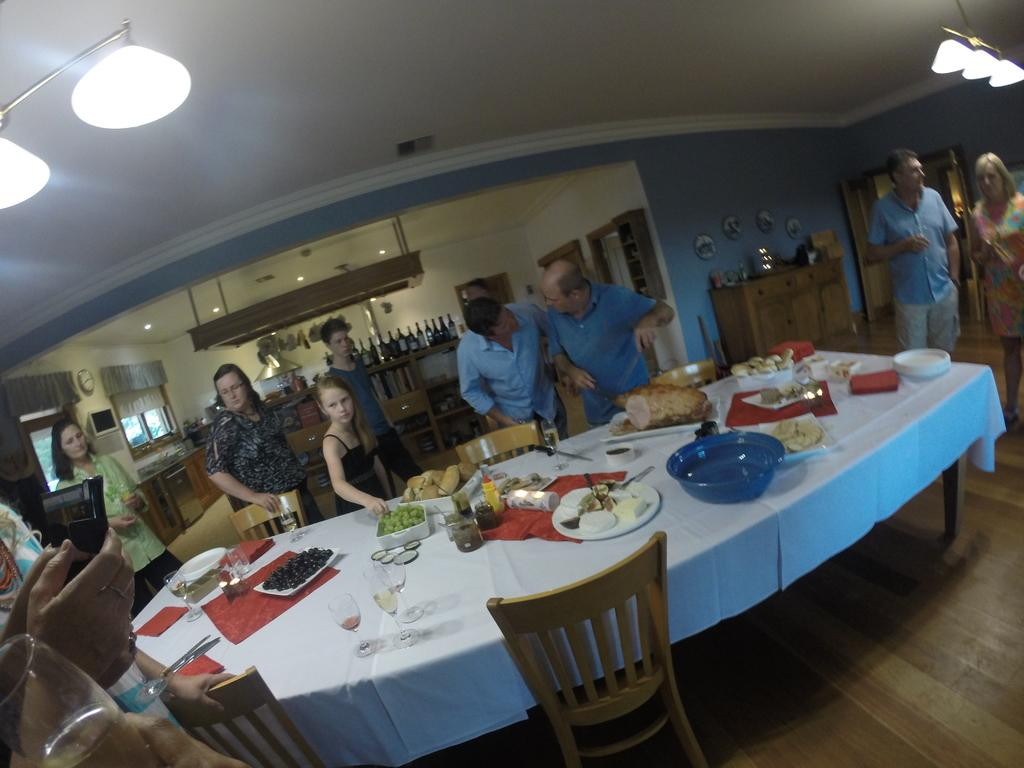Where was the image taken? The image was taken inside a house. How many people are in the image? There are multiple people in the image. What can be seen in the center of the room? There is a white center table in the image. What is on the table? Eatables are present on the table. What type of plastic material is used to make the respect in the image? There is no plastic or respect present in the image. 